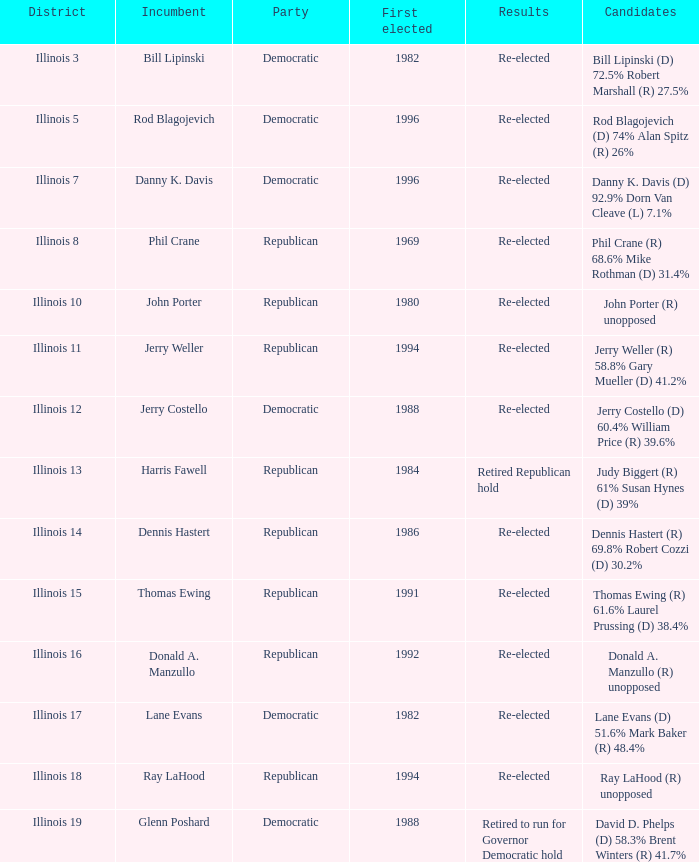Parse the full table. {'header': ['District', 'Incumbent', 'Party', 'First elected', 'Results', 'Candidates'], 'rows': [['Illinois 3', 'Bill Lipinski', 'Democratic', '1982', 'Re-elected', 'Bill Lipinski (D) 72.5% Robert Marshall (R) 27.5%'], ['Illinois 5', 'Rod Blagojevich', 'Democratic', '1996', 'Re-elected', 'Rod Blagojevich (D) 74% Alan Spitz (R) 26%'], ['Illinois 7', 'Danny K. Davis', 'Democratic', '1996', 'Re-elected', 'Danny K. Davis (D) 92.9% Dorn Van Cleave (L) 7.1%'], ['Illinois 8', 'Phil Crane', 'Republican', '1969', 'Re-elected', 'Phil Crane (R) 68.6% Mike Rothman (D) 31.4%'], ['Illinois 10', 'John Porter', 'Republican', '1980', 'Re-elected', 'John Porter (R) unopposed'], ['Illinois 11', 'Jerry Weller', 'Republican', '1994', 'Re-elected', 'Jerry Weller (R) 58.8% Gary Mueller (D) 41.2%'], ['Illinois 12', 'Jerry Costello', 'Democratic', '1988', 'Re-elected', 'Jerry Costello (D) 60.4% William Price (R) 39.6%'], ['Illinois 13', 'Harris Fawell', 'Republican', '1984', 'Retired Republican hold', 'Judy Biggert (R) 61% Susan Hynes (D) 39%'], ['Illinois 14', 'Dennis Hastert', 'Republican', '1986', 'Re-elected', 'Dennis Hastert (R) 69.8% Robert Cozzi (D) 30.2%'], ['Illinois 15', 'Thomas Ewing', 'Republican', '1991', 'Re-elected', 'Thomas Ewing (R) 61.6% Laurel Prussing (D) 38.4%'], ['Illinois 16', 'Donald A. Manzullo', 'Republican', '1992', 'Re-elected', 'Donald A. Manzullo (R) unopposed'], ['Illinois 17', 'Lane Evans', 'Democratic', '1982', 'Re-elected', 'Lane Evans (D) 51.6% Mark Baker (R) 48.4%'], ['Illinois 18', 'Ray LaHood', 'Republican', '1994', 'Re-elected', 'Ray LaHood (R) unopposed'], ['Illinois 19', 'Glenn Poshard', 'Democratic', '1988', 'Retired to run for Governor Democratic hold', 'David D. Phelps (D) 58.3% Brent Winters (R) 41.7%']]} Who were the candidates in the district where Jerry Costello won? Jerry Costello (D) 60.4% William Price (R) 39.6%. 